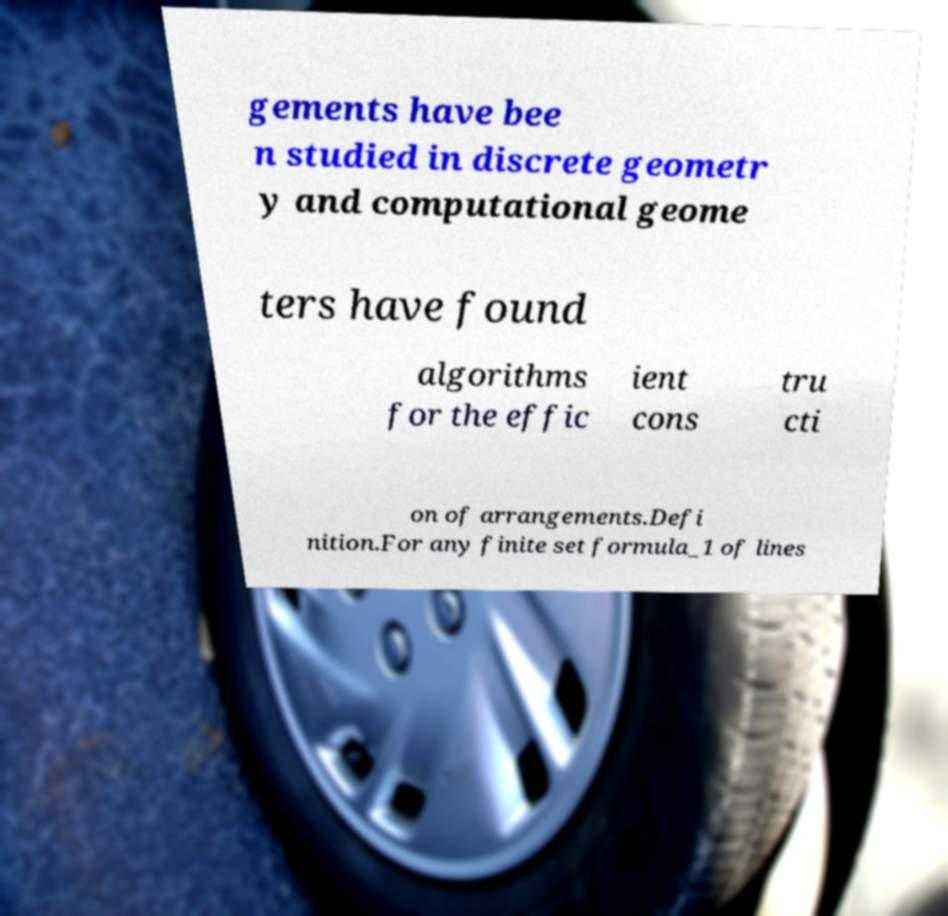I need the written content from this picture converted into text. Can you do that? gements have bee n studied in discrete geometr y and computational geome ters have found algorithms for the effic ient cons tru cti on of arrangements.Defi nition.For any finite set formula_1 of lines 